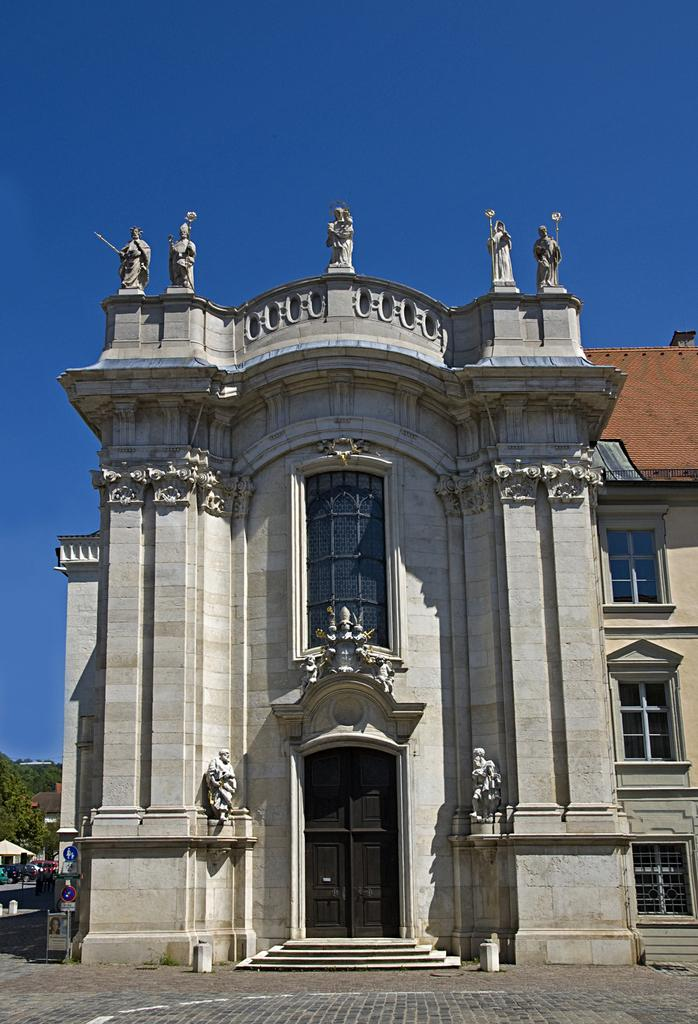What type of structures can be seen in the image? There are buildings in the image. Are there any specific features on the buildings? Yes, there are statues on one of the buildings. What other objects can be seen in the image? There are boards and poles in the image. What type of vegetation is present in the image? There are trees in the image. What is the color of the sky in the background of the image? The sky is blue in the background of the image. What type of meal is being prepared in the image? There is no indication of a meal being prepared in the image. The image primarily features buildings, statues, boards, poles, trees, and a blue sky. 